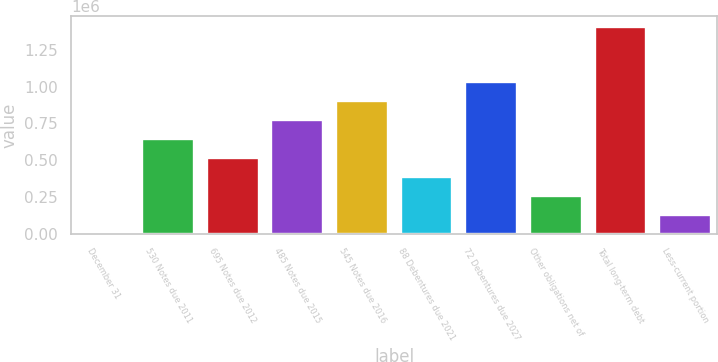Convert chart to OTSL. <chart><loc_0><loc_0><loc_500><loc_500><bar_chart><fcel>December 31<fcel>530 Notes due 2011<fcel>695 Notes due 2012<fcel>485 Notes due 2015<fcel>545 Notes due 2016<fcel>88 Debentures due 2021<fcel>72 Debentures due 2027<fcel>Other obligations net of<fcel>Total long-term debt<fcel>Less-current portion<nl><fcel>2007<fcel>644038<fcel>515632<fcel>772444<fcel>900850<fcel>387226<fcel>1.02926e+06<fcel>258819<fcel>1.40837e+06<fcel>130413<nl></chart> 